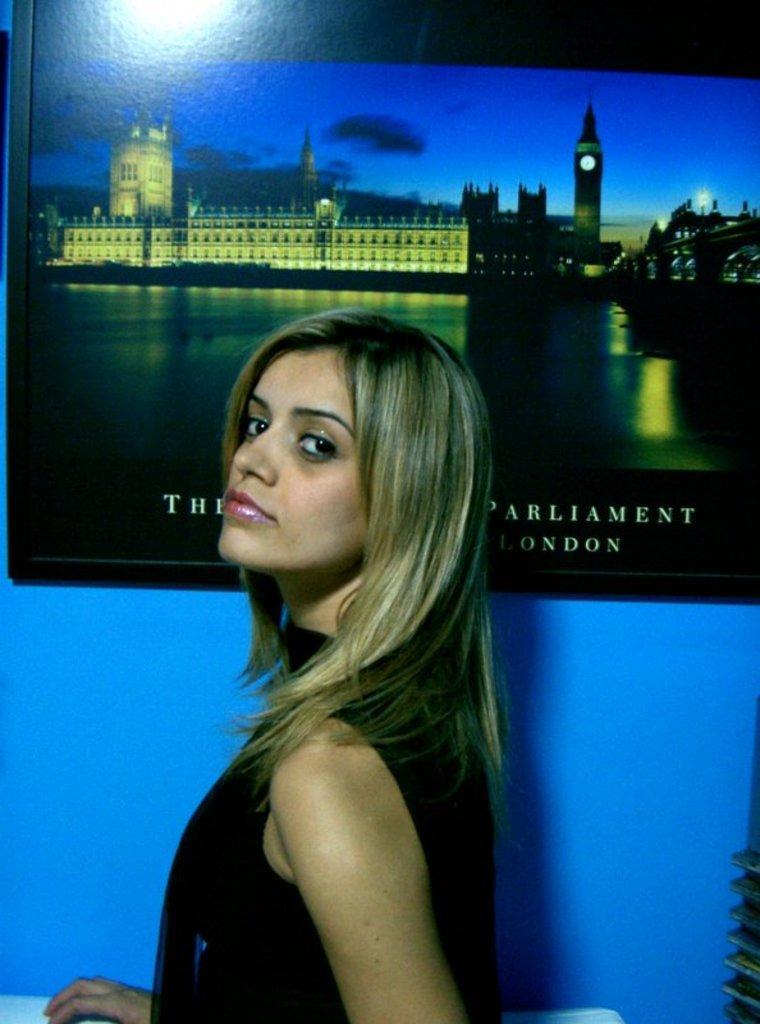Can you describe this image briefly? In this image we can see a woman and picture is on the blue wall. We can see buildings, sky, tower and something written on the picture. 